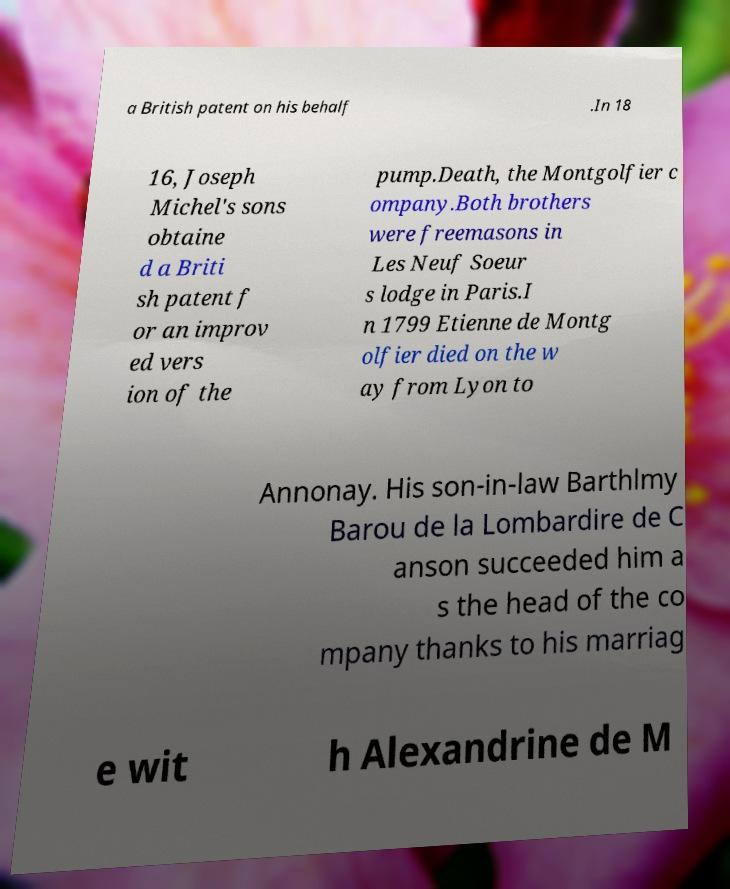Can you accurately transcribe the text from the provided image for me? a British patent on his behalf .In 18 16, Joseph Michel's sons obtaine d a Briti sh patent f or an improv ed vers ion of the pump.Death, the Montgolfier c ompany.Both brothers were freemasons in Les Neuf Soeur s lodge in Paris.I n 1799 Etienne de Montg olfier died on the w ay from Lyon to Annonay. His son-in-law Barthlmy Barou de la Lombardire de C anson succeeded him a s the head of the co mpany thanks to his marriag e wit h Alexandrine de M 